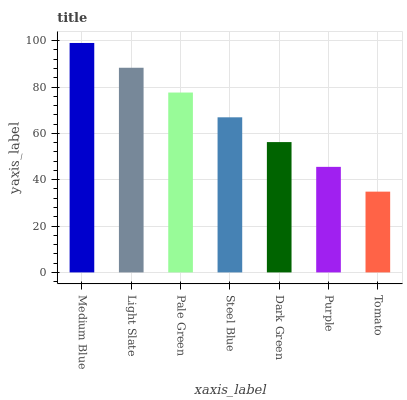Is Tomato the minimum?
Answer yes or no. Yes. Is Medium Blue the maximum?
Answer yes or no. Yes. Is Light Slate the minimum?
Answer yes or no. No. Is Light Slate the maximum?
Answer yes or no. No. Is Medium Blue greater than Light Slate?
Answer yes or no. Yes. Is Light Slate less than Medium Blue?
Answer yes or no. Yes. Is Light Slate greater than Medium Blue?
Answer yes or no. No. Is Medium Blue less than Light Slate?
Answer yes or no. No. Is Steel Blue the high median?
Answer yes or no. Yes. Is Steel Blue the low median?
Answer yes or no. Yes. Is Tomato the high median?
Answer yes or no. No. Is Medium Blue the low median?
Answer yes or no. No. 